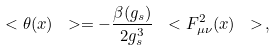Convert formula to latex. <formula><loc_0><loc_0><loc_500><loc_500>\ < \theta ( x ) \ > = - \frac { \beta ( g _ { s } ) } { 2 g _ { s } ^ { 3 } } \ < F _ { \mu \nu } ^ { 2 } ( x ) \ > \, ,</formula> 